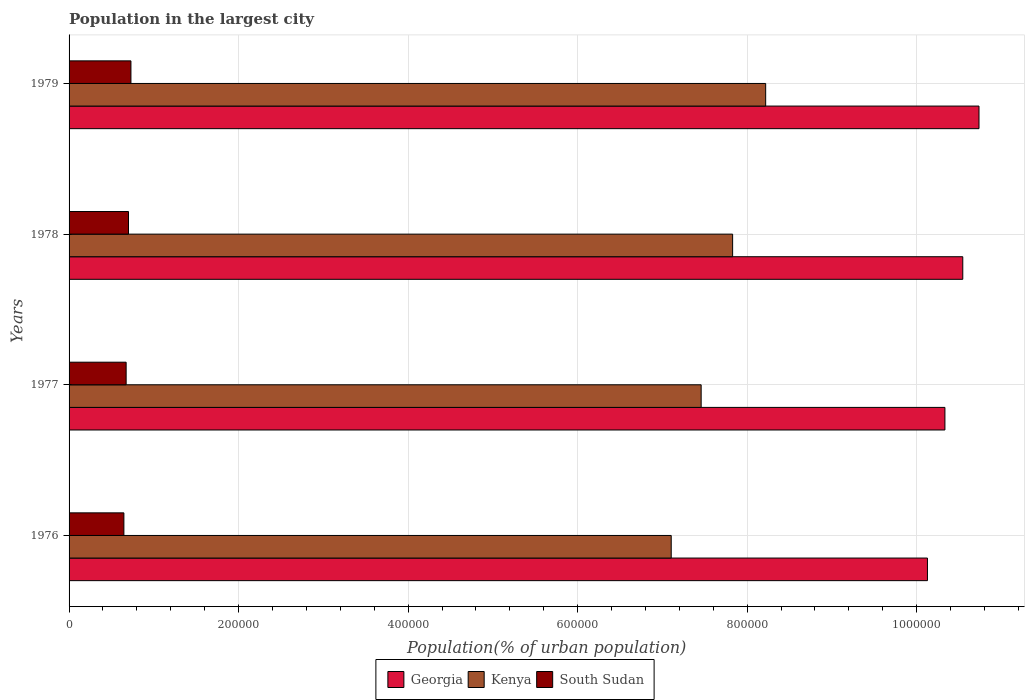How many groups of bars are there?
Offer a terse response. 4. Are the number of bars per tick equal to the number of legend labels?
Offer a terse response. Yes. Are the number of bars on each tick of the Y-axis equal?
Keep it short and to the point. Yes. What is the population in the largest city in Kenya in 1976?
Provide a short and direct response. 7.10e+05. Across all years, what is the maximum population in the largest city in South Sudan?
Provide a succinct answer. 7.30e+04. Across all years, what is the minimum population in the largest city in Georgia?
Provide a short and direct response. 1.01e+06. In which year was the population in the largest city in Kenya maximum?
Your response must be concise. 1979. In which year was the population in the largest city in South Sudan minimum?
Your answer should be very brief. 1976. What is the total population in the largest city in Georgia in the graph?
Keep it short and to the point. 4.17e+06. What is the difference between the population in the largest city in Georgia in 1976 and that in 1977?
Your response must be concise. -2.06e+04. What is the difference between the population in the largest city in Kenya in 1979 and the population in the largest city in South Sudan in 1976?
Your answer should be very brief. 7.57e+05. What is the average population in the largest city in South Sudan per year?
Your answer should be compact. 6.88e+04. In the year 1979, what is the difference between the population in the largest city in South Sudan and population in the largest city in Kenya?
Make the answer very short. -7.49e+05. In how many years, is the population in the largest city in Kenya greater than 1040000 %?
Give a very brief answer. 0. What is the ratio of the population in the largest city in Kenya in 1978 to that in 1979?
Offer a terse response. 0.95. Is the population in the largest city in Kenya in 1976 less than that in 1979?
Offer a terse response. Yes. Is the difference between the population in the largest city in South Sudan in 1978 and 1979 greater than the difference between the population in the largest city in Kenya in 1978 and 1979?
Provide a succinct answer. Yes. What is the difference between the highest and the second highest population in the largest city in Kenya?
Make the answer very short. 3.90e+04. What is the difference between the highest and the lowest population in the largest city in South Sudan?
Provide a short and direct response. 8321. In how many years, is the population in the largest city in South Sudan greater than the average population in the largest city in South Sudan taken over all years?
Keep it short and to the point. 2. Is the sum of the population in the largest city in South Sudan in 1977 and 1978 greater than the maximum population in the largest city in Georgia across all years?
Offer a very short reply. No. What does the 2nd bar from the top in 1979 represents?
Provide a succinct answer. Kenya. What does the 3rd bar from the bottom in 1978 represents?
Offer a terse response. South Sudan. Does the graph contain any zero values?
Provide a succinct answer. No. How many legend labels are there?
Offer a very short reply. 3. What is the title of the graph?
Your answer should be very brief. Population in the largest city. What is the label or title of the X-axis?
Offer a terse response. Population(% of urban population). What is the Population(% of urban population) in Georgia in 1976?
Keep it short and to the point. 1.01e+06. What is the Population(% of urban population) of Kenya in 1976?
Your answer should be compact. 7.10e+05. What is the Population(% of urban population) in South Sudan in 1976?
Keep it short and to the point. 6.47e+04. What is the Population(% of urban population) in Georgia in 1977?
Offer a terse response. 1.03e+06. What is the Population(% of urban population) in Kenya in 1977?
Provide a succinct answer. 7.46e+05. What is the Population(% of urban population) of South Sudan in 1977?
Your answer should be very brief. 6.73e+04. What is the Population(% of urban population) in Georgia in 1978?
Keep it short and to the point. 1.05e+06. What is the Population(% of urban population) in Kenya in 1978?
Make the answer very short. 7.83e+05. What is the Population(% of urban population) of South Sudan in 1978?
Offer a very short reply. 7.01e+04. What is the Population(% of urban population) of Georgia in 1979?
Your response must be concise. 1.07e+06. What is the Population(% of urban population) in Kenya in 1979?
Provide a succinct answer. 8.22e+05. What is the Population(% of urban population) of South Sudan in 1979?
Your answer should be compact. 7.30e+04. Across all years, what is the maximum Population(% of urban population) in Georgia?
Your answer should be compact. 1.07e+06. Across all years, what is the maximum Population(% of urban population) of Kenya?
Your answer should be very brief. 8.22e+05. Across all years, what is the maximum Population(% of urban population) in South Sudan?
Ensure brevity in your answer.  7.30e+04. Across all years, what is the minimum Population(% of urban population) in Georgia?
Offer a terse response. 1.01e+06. Across all years, what is the minimum Population(% of urban population) of Kenya?
Your answer should be very brief. 7.10e+05. Across all years, what is the minimum Population(% of urban population) of South Sudan?
Offer a terse response. 6.47e+04. What is the total Population(% of urban population) in Georgia in the graph?
Ensure brevity in your answer.  4.17e+06. What is the total Population(% of urban population) in Kenya in the graph?
Your response must be concise. 3.06e+06. What is the total Population(% of urban population) in South Sudan in the graph?
Ensure brevity in your answer.  2.75e+05. What is the difference between the Population(% of urban population) of Georgia in 1976 and that in 1977?
Offer a terse response. -2.06e+04. What is the difference between the Population(% of urban population) in Kenya in 1976 and that in 1977?
Provide a short and direct response. -3.53e+04. What is the difference between the Population(% of urban population) in South Sudan in 1976 and that in 1977?
Give a very brief answer. -2660. What is the difference between the Population(% of urban population) in Georgia in 1976 and that in 1978?
Provide a succinct answer. -4.17e+04. What is the difference between the Population(% of urban population) of Kenya in 1976 and that in 1978?
Provide a succinct answer. -7.24e+04. What is the difference between the Population(% of urban population) of South Sudan in 1976 and that in 1978?
Give a very brief answer. -5434. What is the difference between the Population(% of urban population) of Georgia in 1976 and that in 1979?
Offer a very short reply. -6.08e+04. What is the difference between the Population(% of urban population) of Kenya in 1976 and that in 1979?
Offer a very short reply. -1.11e+05. What is the difference between the Population(% of urban population) of South Sudan in 1976 and that in 1979?
Offer a very short reply. -8321. What is the difference between the Population(% of urban population) of Georgia in 1977 and that in 1978?
Your answer should be very brief. -2.11e+04. What is the difference between the Population(% of urban population) in Kenya in 1977 and that in 1978?
Your answer should be compact. -3.71e+04. What is the difference between the Population(% of urban population) in South Sudan in 1977 and that in 1978?
Keep it short and to the point. -2774. What is the difference between the Population(% of urban population) in Georgia in 1977 and that in 1979?
Your response must be concise. -4.02e+04. What is the difference between the Population(% of urban population) in Kenya in 1977 and that in 1979?
Give a very brief answer. -7.61e+04. What is the difference between the Population(% of urban population) of South Sudan in 1977 and that in 1979?
Ensure brevity in your answer.  -5661. What is the difference between the Population(% of urban population) of Georgia in 1978 and that in 1979?
Offer a terse response. -1.91e+04. What is the difference between the Population(% of urban population) of Kenya in 1978 and that in 1979?
Provide a succinct answer. -3.90e+04. What is the difference between the Population(% of urban population) of South Sudan in 1978 and that in 1979?
Make the answer very short. -2887. What is the difference between the Population(% of urban population) in Georgia in 1976 and the Population(% of urban population) in Kenya in 1977?
Offer a terse response. 2.67e+05. What is the difference between the Population(% of urban population) in Georgia in 1976 and the Population(% of urban population) in South Sudan in 1977?
Make the answer very short. 9.45e+05. What is the difference between the Population(% of urban population) in Kenya in 1976 and the Population(% of urban population) in South Sudan in 1977?
Give a very brief answer. 6.43e+05. What is the difference between the Population(% of urban population) of Georgia in 1976 and the Population(% of urban population) of Kenya in 1978?
Make the answer very short. 2.30e+05. What is the difference between the Population(% of urban population) of Georgia in 1976 and the Population(% of urban population) of South Sudan in 1978?
Ensure brevity in your answer.  9.43e+05. What is the difference between the Population(% of urban population) in Kenya in 1976 and the Population(% of urban population) in South Sudan in 1978?
Give a very brief answer. 6.40e+05. What is the difference between the Population(% of urban population) of Georgia in 1976 and the Population(% of urban population) of Kenya in 1979?
Your answer should be very brief. 1.91e+05. What is the difference between the Population(% of urban population) of Georgia in 1976 and the Population(% of urban population) of South Sudan in 1979?
Give a very brief answer. 9.40e+05. What is the difference between the Population(% of urban population) in Kenya in 1976 and the Population(% of urban population) in South Sudan in 1979?
Offer a very short reply. 6.37e+05. What is the difference between the Population(% of urban population) of Georgia in 1977 and the Population(% of urban population) of Kenya in 1978?
Offer a very short reply. 2.50e+05. What is the difference between the Population(% of urban population) in Georgia in 1977 and the Population(% of urban population) in South Sudan in 1978?
Make the answer very short. 9.63e+05. What is the difference between the Population(% of urban population) of Kenya in 1977 and the Population(% of urban population) of South Sudan in 1978?
Provide a succinct answer. 6.76e+05. What is the difference between the Population(% of urban population) in Georgia in 1977 and the Population(% of urban population) in Kenya in 1979?
Provide a succinct answer. 2.11e+05. What is the difference between the Population(% of urban population) in Georgia in 1977 and the Population(% of urban population) in South Sudan in 1979?
Provide a succinct answer. 9.60e+05. What is the difference between the Population(% of urban population) of Kenya in 1977 and the Population(% of urban population) of South Sudan in 1979?
Provide a succinct answer. 6.73e+05. What is the difference between the Population(% of urban population) of Georgia in 1978 and the Population(% of urban population) of Kenya in 1979?
Make the answer very short. 2.33e+05. What is the difference between the Population(% of urban population) in Georgia in 1978 and the Population(% of urban population) in South Sudan in 1979?
Give a very brief answer. 9.81e+05. What is the difference between the Population(% of urban population) of Kenya in 1978 and the Population(% of urban population) of South Sudan in 1979?
Your response must be concise. 7.10e+05. What is the average Population(% of urban population) of Georgia per year?
Keep it short and to the point. 1.04e+06. What is the average Population(% of urban population) in Kenya per year?
Give a very brief answer. 7.65e+05. What is the average Population(% of urban population) in South Sudan per year?
Offer a terse response. 6.88e+04. In the year 1976, what is the difference between the Population(% of urban population) of Georgia and Population(% of urban population) of Kenya?
Ensure brevity in your answer.  3.02e+05. In the year 1976, what is the difference between the Population(% of urban population) of Georgia and Population(% of urban population) of South Sudan?
Your answer should be compact. 9.48e+05. In the year 1976, what is the difference between the Population(% of urban population) of Kenya and Population(% of urban population) of South Sudan?
Make the answer very short. 6.46e+05. In the year 1977, what is the difference between the Population(% of urban population) in Georgia and Population(% of urban population) in Kenya?
Offer a very short reply. 2.88e+05. In the year 1977, what is the difference between the Population(% of urban population) in Georgia and Population(% of urban population) in South Sudan?
Provide a succinct answer. 9.66e+05. In the year 1977, what is the difference between the Population(% of urban population) in Kenya and Population(% of urban population) in South Sudan?
Provide a short and direct response. 6.78e+05. In the year 1978, what is the difference between the Population(% of urban population) of Georgia and Population(% of urban population) of Kenya?
Offer a terse response. 2.72e+05. In the year 1978, what is the difference between the Population(% of urban population) of Georgia and Population(% of urban population) of South Sudan?
Ensure brevity in your answer.  9.84e+05. In the year 1978, what is the difference between the Population(% of urban population) in Kenya and Population(% of urban population) in South Sudan?
Provide a short and direct response. 7.13e+05. In the year 1979, what is the difference between the Population(% of urban population) in Georgia and Population(% of urban population) in Kenya?
Your answer should be very brief. 2.52e+05. In the year 1979, what is the difference between the Population(% of urban population) of Georgia and Population(% of urban population) of South Sudan?
Your answer should be very brief. 1.00e+06. In the year 1979, what is the difference between the Population(% of urban population) in Kenya and Population(% of urban population) in South Sudan?
Offer a terse response. 7.49e+05. What is the ratio of the Population(% of urban population) of Georgia in 1976 to that in 1977?
Provide a short and direct response. 0.98. What is the ratio of the Population(% of urban population) of Kenya in 1976 to that in 1977?
Make the answer very short. 0.95. What is the ratio of the Population(% of urban population) in South Sudan in 1976 to that in 1977?
Keep it short and to the point. 0.96. What is the ratio of the Population(% of urban population) of Georgia in 1976 to that in 1978?
Keep it short and to the point. 0.96. What is the ratio of the Population(% of urban population) in Kenya in 1976 to that in 1978?
Your response must be concise. 0.91. What is the ratio of the Population(% of urban population) of South Sudan in 1976 to that in 1978?
Provide a succinct answer. 0.92. What is the ratio of the Population(% of urban population) in Georgia in 1976 to that in 1979?
Keep it short and to the point. 0.94. What is the ratio of the Population(% of urban population) of Kenya in 1976 to that in 1979?
Your answer should be compact. 0.86. What is the ratio of the Population(% of urban population) in South Sudan in 1976 to that in 1979?
Your answer should be very brief. 0.89. What is the ratio of the Population(% of urban population) in Georgia in 1977 to that in 1978?
Provide a short and direct response. 0.98. What is the ratio of the Population(% of urban population) in Kenya in 1977 to that in 1978?
Offer a very short reply. 0.95. What is the ratio of the Population(% of urban population) in South Sudan in 1977 to that in 1978?
Make the answer very short. 0.96. What is the ratio of the Population(% of urban population) in Georgia in 1977 to that in 1979?
Your answer should be very brief. 0.96. What is the ratio of the Population(% of urban population) in Kenya in 1977 to that in 1979?
Offer a very short reply. 0.91. What is the ratio of the Population(% of urban population) in South Sudan in 1977 to that in 1979?
Provide a short and direct response. 0.92. What is the ratio of the Population(% of urban population) in Georgia in 1978 to that in 1979?
Your answer should be very brief. 0.98. What is the ratio of the Population(% of urban population) of Kenya in 1978 to that in 1979?
Ensure brevity in your answer.  0.95. What is the ratio of the Population(% of urban population) of South Sudan in 1978 to that in 1979?
Provide a succinct answer. 0.96. What is the difference between the highest and the second highest Population(% of urban population) of Georgia?
Provide a short and direct response. 1.91e+04. What is the difference between the highest and the second highest Population(% of urban population) in Kenya?
Ensure brevity in your answer.  3.90e+04. What is the difference between the highest and the second highest Population(% of urban population) of South Sudan?
Keep it short and to the point. 2887. What is the difference between the highest and the lowest Population(% of urban population) in Georgia?
Offer a very short reply. 6.08e+04. What is the difference between the highest and the lowest Population(% of urban population) of Kenya?
Give a very brief answer. 1.11e+05. What is the difference between the highest and the lowest Population(% of urban population) of South Sudan?
Give a very brief answer. 8321. 